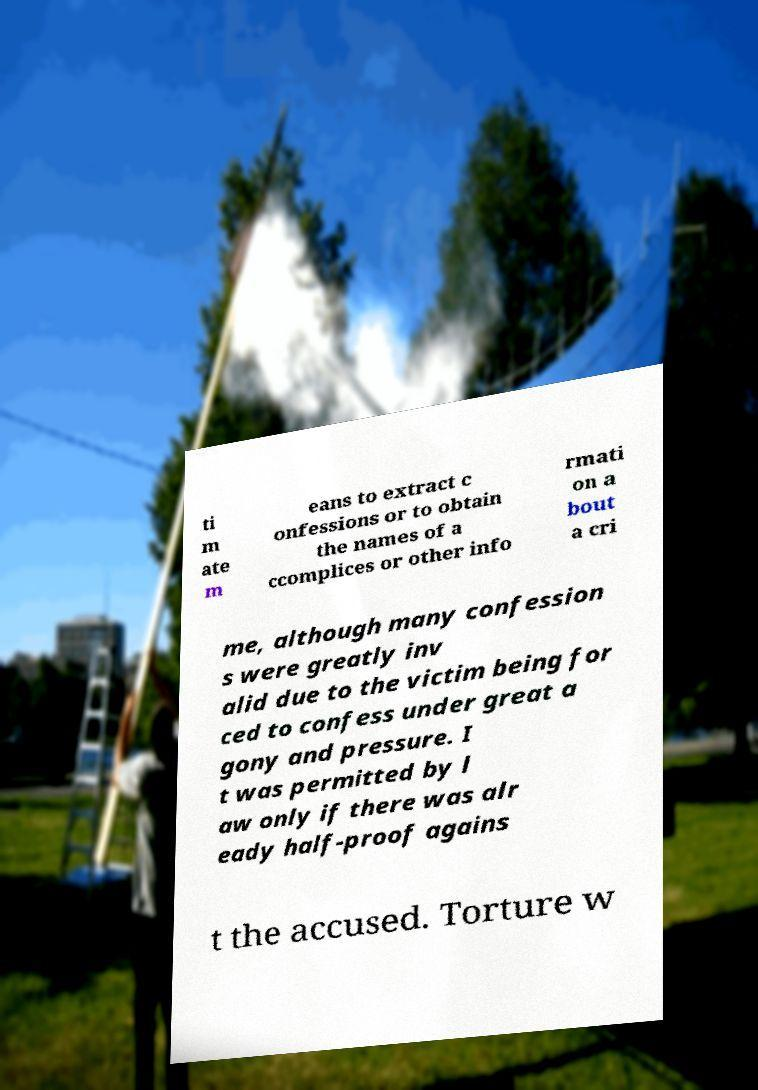What messages or text are displayed in this image? I need them in a readable, typed format. ti m ate m eans to extract c onfessions or to obtain the names of a ccomplices or other info rmati on a bout a cri me, although many confession s were greatly inv alid due to the victim being for ced to confess under great a gony and pressure. I t was permitted by l aw only if there was alr eady half-proof agains t the accused. Torture w 